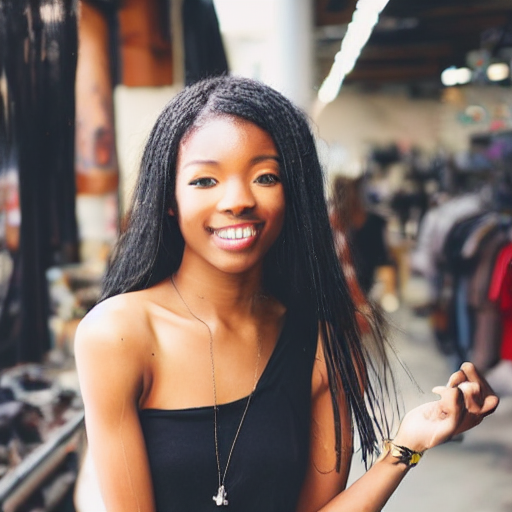Describe the composition of the image.
A. The main subject is obscured.
B. The composition lacks focus.
C. The composition is centered, and the main subject is clearly defined.
Answer with the option's letter from the given choices directly. C. The image features a central focus on a smiling young woman who is the main subject. She is placed in the center of the frame, sharply in focus against a softly blurred background which creates a shallow depth of field. Her positioning, along with the clarity and exposure, draws the viewer's attention directly to her, making the composition well-balanced and visually engaging. 